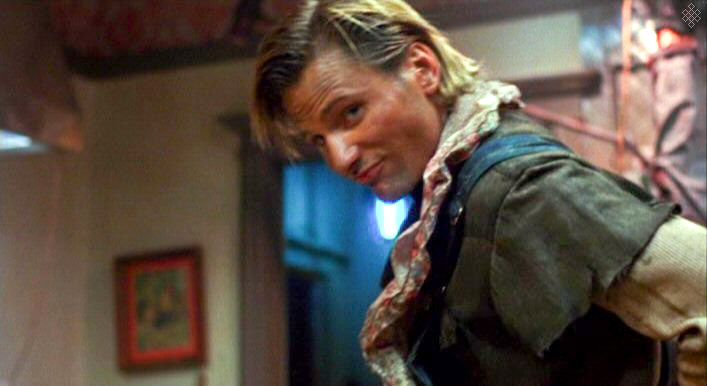What emotion does the man’s expression convey? The man's expression conveys a sense of curiosity mixed with amusement. His slightly raised eyebrow and the slight tilt of his head suggest a playful or inquisitive mood. 